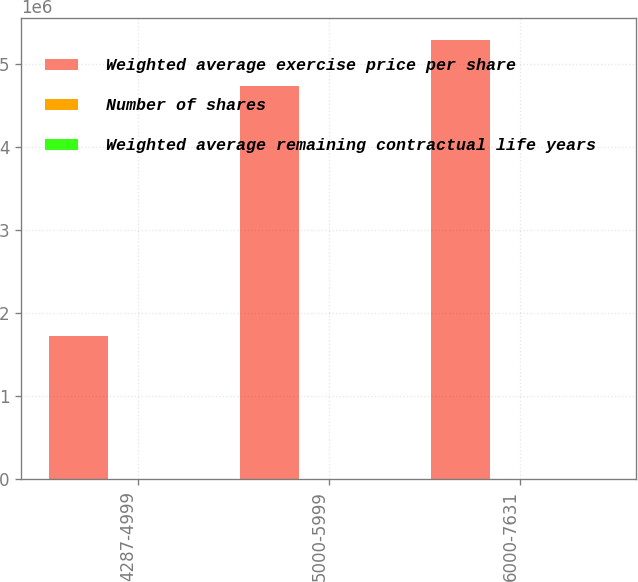Convert chart to OTSL. <chart><loc_0><loc_0><loc_500><loc_500><stacked_bar_chart><ecel><fcel>4287-4999<fcel>5000-5999<fcel>6000-7631<nl><fcel>Weighted average exercise price per share<fcel>1.72144e+06<fcel>4.73099e+06<fcel>5.28559e+06<nl><fcel>Number of shares<fcel>6.44<fcel>5.45<fcel>3.59<nl><fcel>Weighted average remaining contractual life years<fcel>48.07<fcel>55.42<fcel>67.79<nl></chart> 